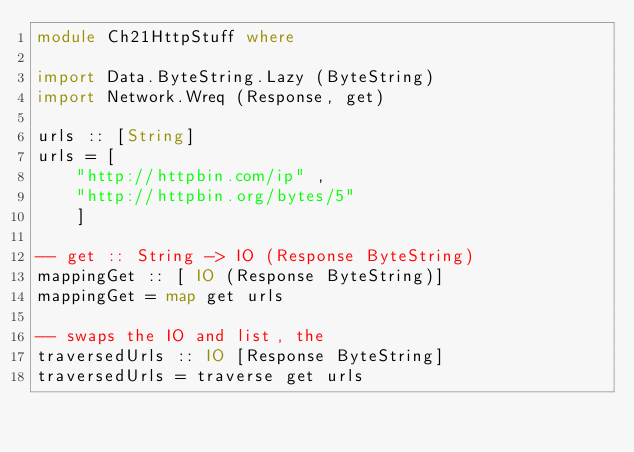<code> <loc_0><loc_0><loc_500><loc_500><_Haskell_>module Ch21HttpStuff where

import Data.ByteString.Lazy (ByteString) 
import Network.Wreq (Response, get)

urls :: [String]
urls = [
    "http://httpbin.com/ip" ,
    "http://httpbin.org/bytes/5"
    ]

-- get :: String -> IO (Response ByteString)
mappingGet :: [ IO (Response ByteString)]
mappingGet = map get urls

-- swaps the IO and list, the 
traversedUrls :: IO [Response ByteString]
traversedUrls = traverse get urls
</code> 